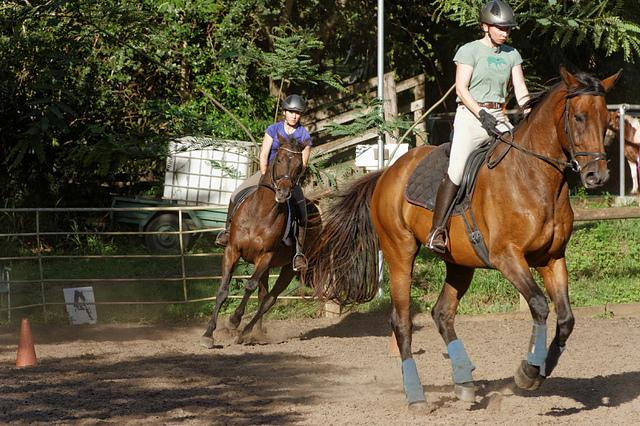Why do the people wear head gear?

Choices:
A) fashion
B) streamlining
C) protection
D) to match protection 